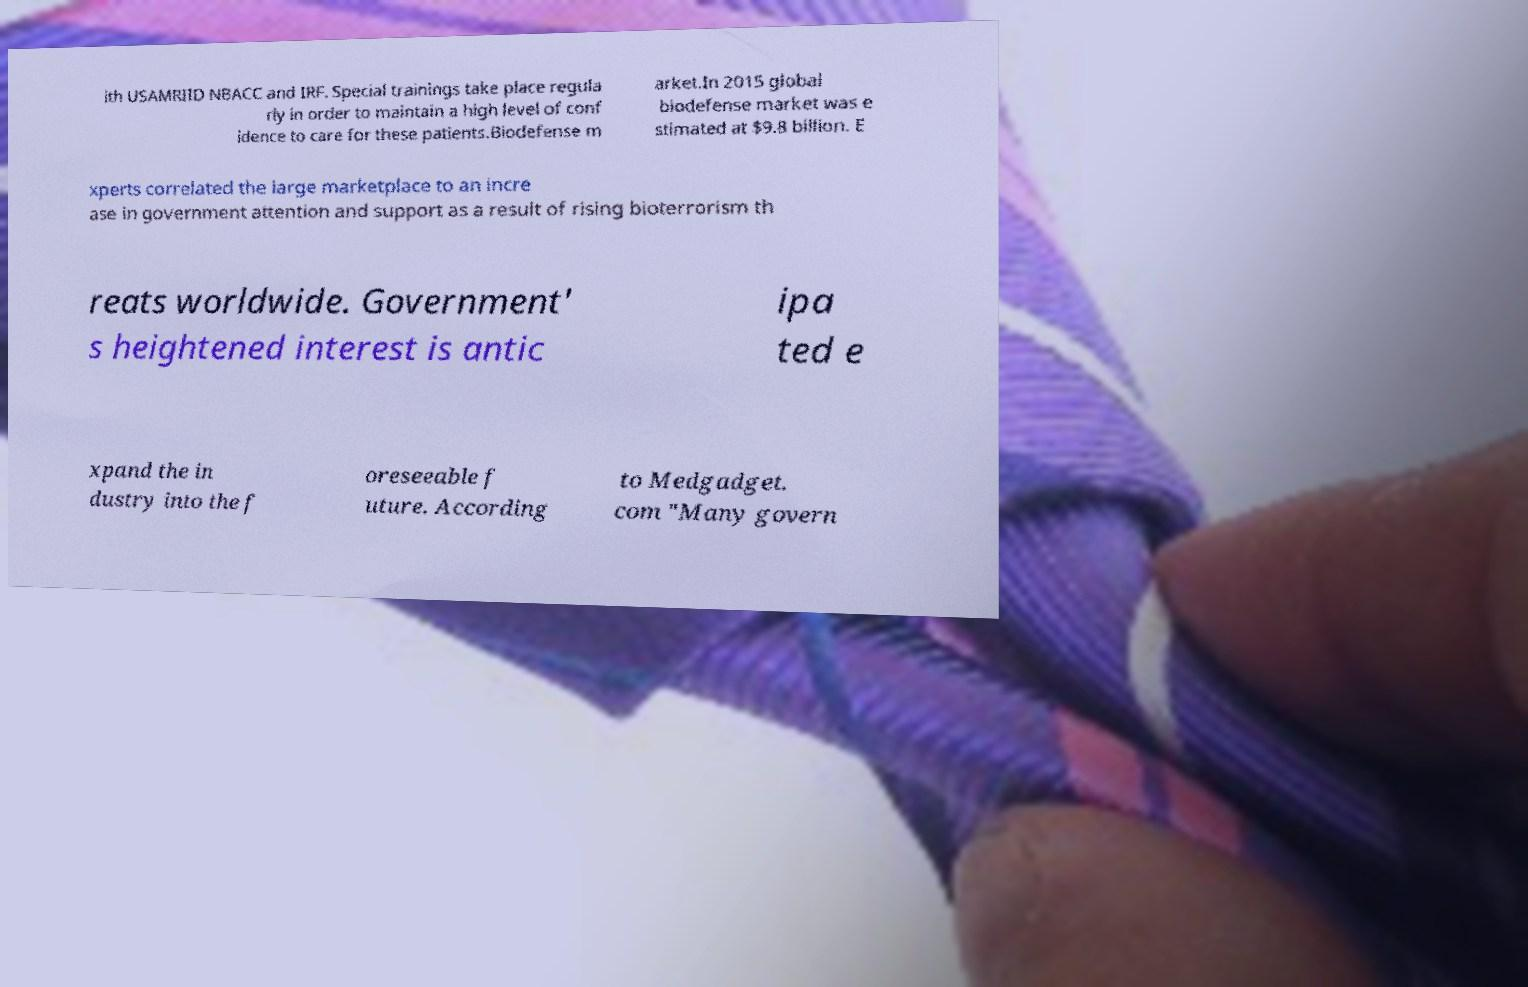There's text embedded in this image that I need extracted. Can you transcribe it verbatim? ith USAMRIID NBACC and IRF. Special trainings take place regula rly in order to maintain a high level of conf idence to care for these patients.Biodefense m arket.In 2015 global biodefense market was e stimated at $9.8 billion. E xperts correlated the large marketplace to an incre ase in government attention and support as a result of rising bioterrorism th reats worldwide. Government' s heightened interest is antic ipa ted e xpand the in dustry into the f oreseeable f uture. According to Medgadget. com "Many govern 